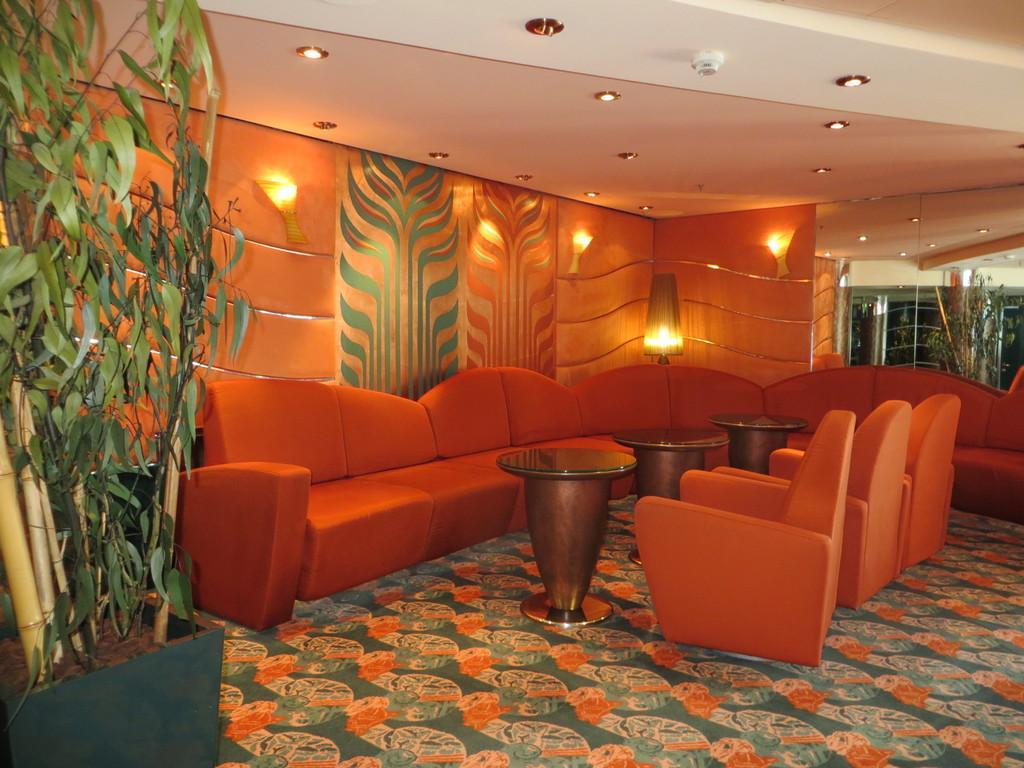Please provide a concise description of this image. in this image the many things are there inside the room like sofas,trees,pots,tables and chairs behind the sofa the light is there and the back ground is full of light 